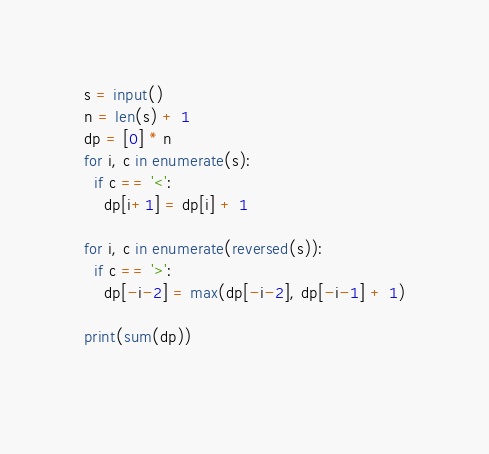Convert code to text. <code><loc_0><loc_0><loc_500><loc_500><_Python_>s = input()
n = len(s) + 1
dp = [0] * n
for i, c in enumerate(s):
  if c == '<':
    dp[i+1] = dp[i] + 1

for i, c in enumerate(reversed(s)):
  if c == '>':
    dp[-i-2] = max(dp[-i-2], dp[-i-1] + 1)

print(sum(dp))
  </code> 